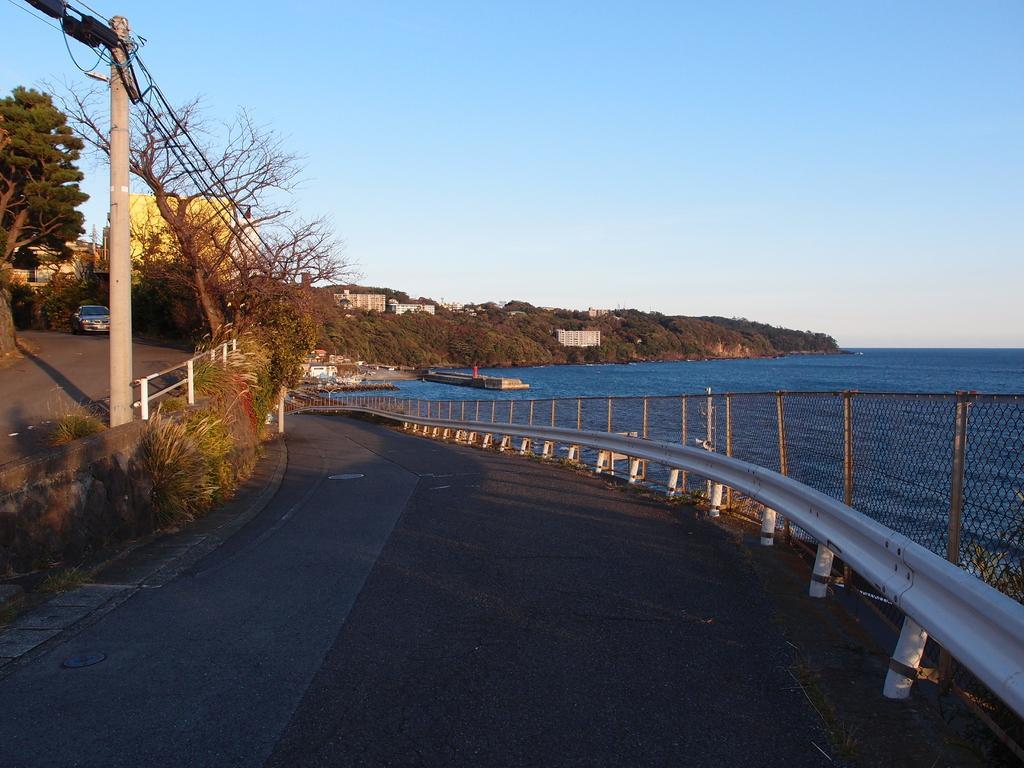Please provide a concise description of this image. In this image I can see the road. To the side of the road I can see the plants, railing and the water. To the left I can see the pole and the vehicle. In the background there are many trees, houses and the sky. 